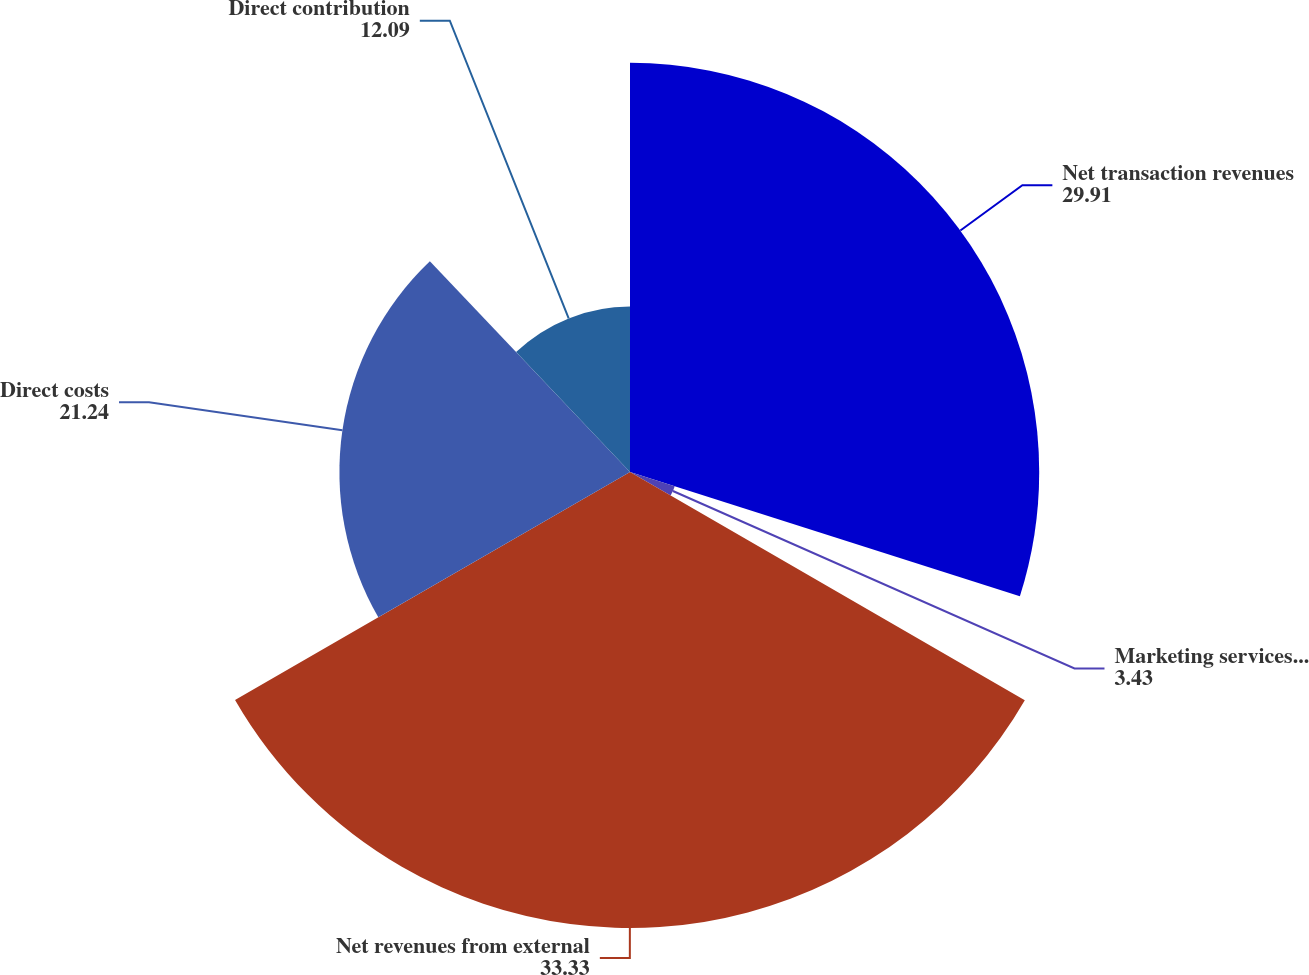Convert chart. <chart><loc_0><loc_0><loc_500><loc_500><pie_chart><fcel>Net transaction revenues<fcel>Marketing services and other<fcel>Net revenues from external<fcel>Direct costs<fcel>Direct contribution<nl><fcel>29.91%<fcel>3.43%<fcel>33.33%<fcel>21.24%<fcel>12.09%<nl></chart> 